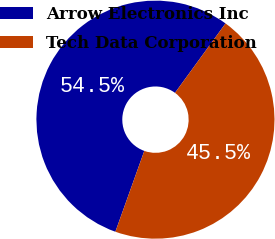Convert chart to OTSL. <chart><loc_0><loc_0><loc_500><loc_500><pie_chart><fcel>Arrow Electronics Inc<fcel>Tech Data Corporation<nl><fcel>54.55%<fcel>45.45%<nl></chart> 